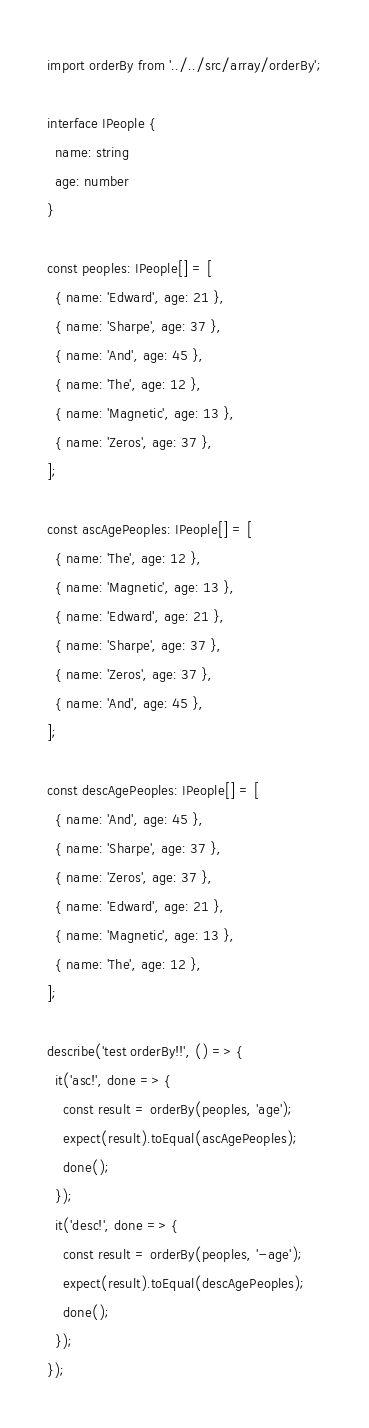Convert code to text. <code><loc_0><loc_0><loc_500><loc_500><_TypeScript_>import orderBy from '../../src/array/orderBy';

interface IPeople {
  name: string
  age: number
}

const peoples: IPeople[] = [
  { name: 'Edward', age: 21 },
  { name: 'Sharpe', age: 37 },
  { name: 'And', age: 45 },
  { name: 'The', age: 12 },
  { name: 'Magnetic', age: 13 },
  { name: 'Zeros', age: 37 },
];

const ascAgePeoples: IPeople[] = [
  { name: 'The', age: 12 },
  { name: 'Magnetic', age: 13 },
  { name: 'Edward', age: 21 },
  { name: 'Sharpe', age: 37 },
  { name: 'Zeros', age: 37 },
  { name: 'And', age: 45 },
];

const descAgePeoples: IPeople[] = [
  { name: 'And', age: 45 },
  { name: 'Sharpe', age: 37 },
  { name: 'Zeros', age: 37 },
  { name: 'Edward', age: 21 },
  { name: 'Magnetic', age: 13 },
  { name: 'The', age: 12 },
];

describe('test orderBy!!', () => {
  it('asc!', done => {
    const result = orderBy(peoples, 'age');
    expect(result).toEqual(ascAgePeoples);
    done();
  });
  it('desc!', done => {
    const result = orderBy(peoples, '-age');
    expect(result).toEqual(descAgePeoples);
    done();
  });
});
</code> 